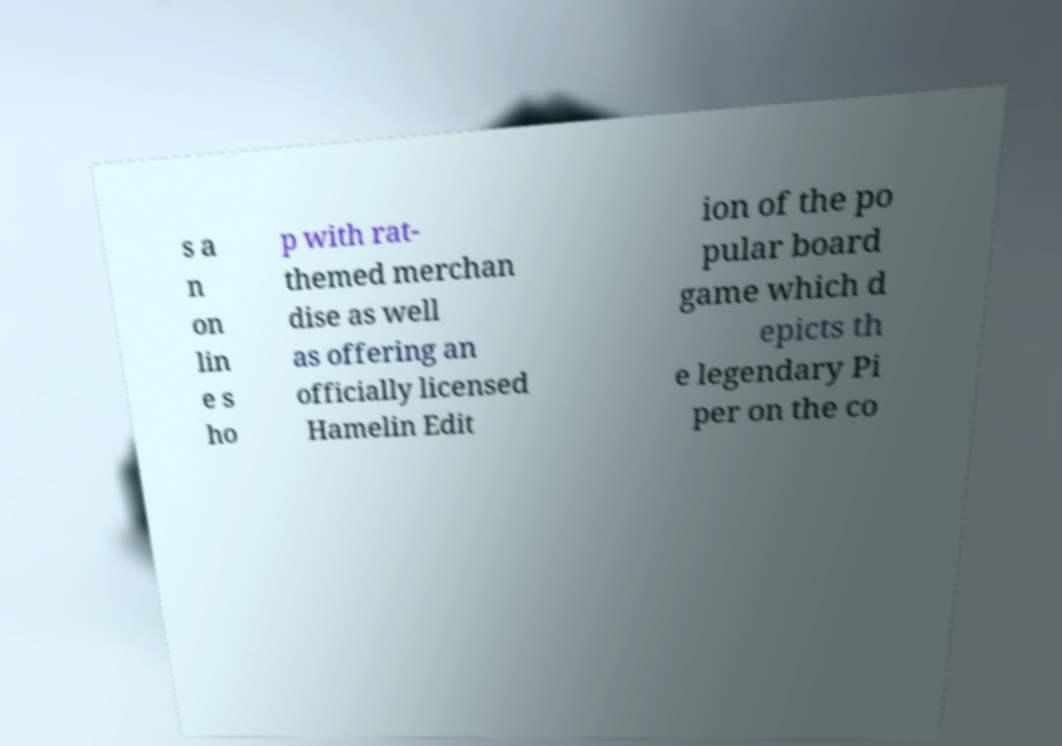Can you accurately transcribe the text from the provided image for me? s a n on lin e s ho p with rat- themed merchan dise as well as offering an officially licensed Hamelin Edit ion of the po pular board game which d epicts th e legendary Pi per on the co 